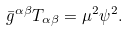Convert formula to latex. <formula><loc_0><loc_0><loc_500><loc_500>\bar { g } ^ { \alpha \beta } T _ { \alpha \beta } = \mu ^ { 2 } \psi ^ { 2 } .</formula> 